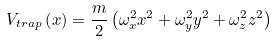Convert formula to latex. <formula><loc_0><loc_0><loc_500><loc_500>V _ { t r a p } \left ( x \right ) = \frac { m } { 2 } \left ( \omega _ { x } ^ { 2 } x ^ { 2 } + \omega _ { y } ^ { 2 } y ^ { 2 } + \omega _ { z } ^ { 2 } z ^ { 2 } \right )</formula> 